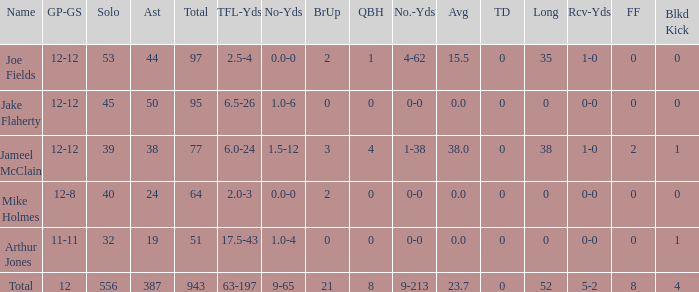What is the total brup for the team? 21.0. 